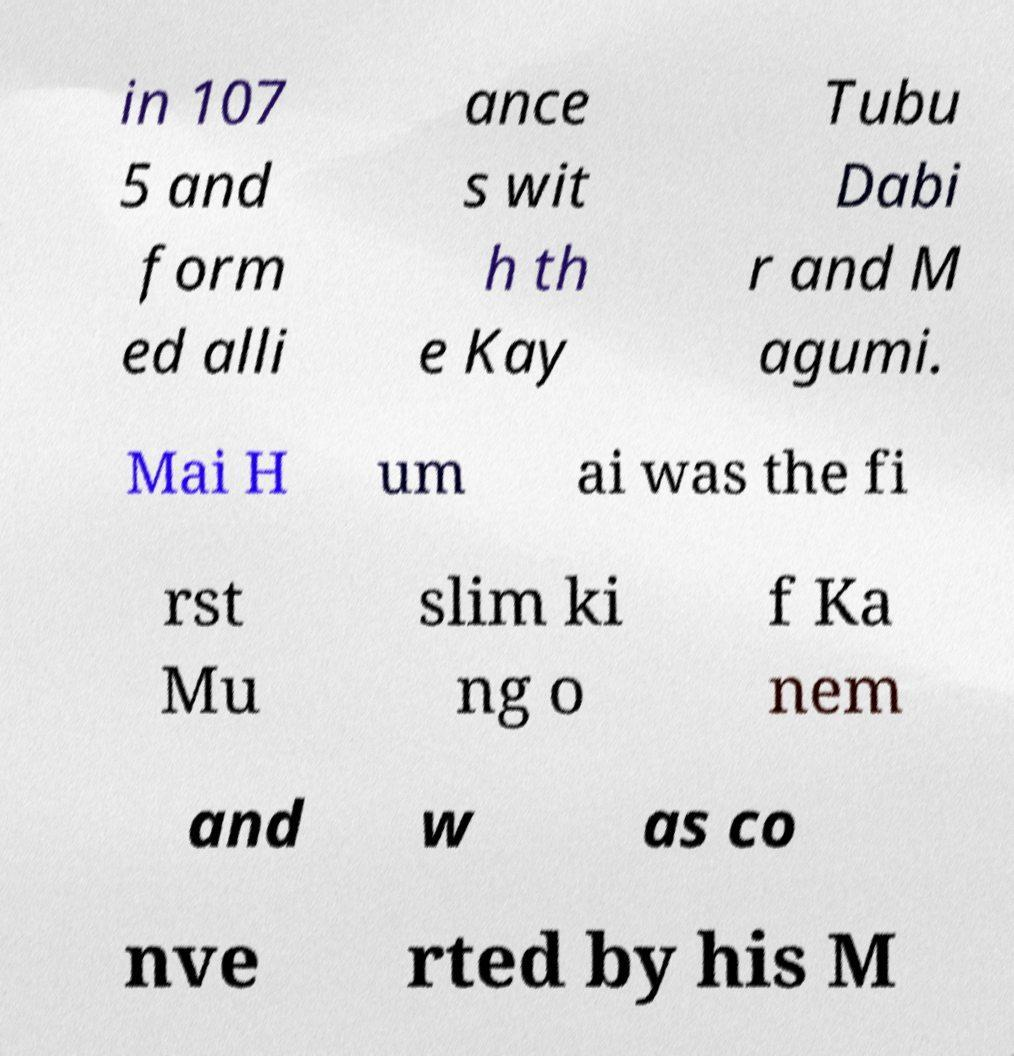Please identify and transcribe the text found in this image. in 107 5 and form ed alli ance s wit h th e Kay Tubu Dabi r and M agumi. Mai H um ai was the fi rst Mu slim ki ng o f Ka nem and w as co nve rted by his M 